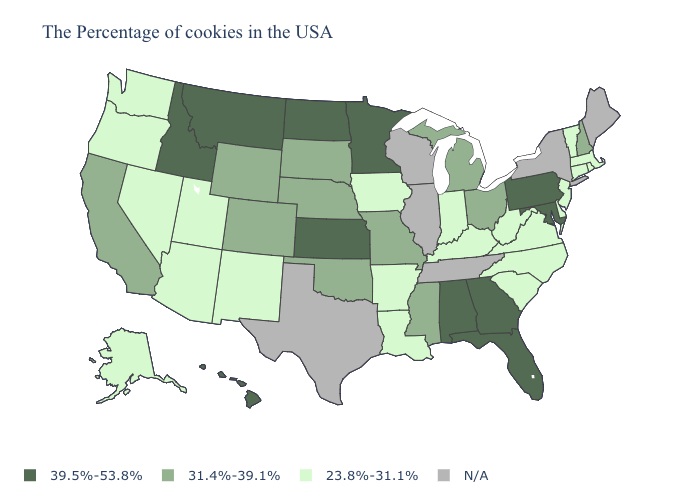What is the value of New Mexico?
Give a very brief answer. 23.8%-31.1%. Which states hav the highest value in the West?
Concise answer only. Montana, Idaho, Hawaii. Name the states that have a value in the range N/A?
Be succinct. Maine, New York, Tennessee, Wisconsin, Illinois, Texas. What is the value of Illinois?
Give a very brief answer. N/A. What is the value of South Carolina?
Give a very brief answer. 23.8%-31.1%. Among the states that border Missouri , which have the highest value?
Short answer required. Kansas. Is the legend a continuous bar?
Quick response, please. No. Name the states that have a value in the range 39.5%-53.8%?
Give a very brief answer. Maryland, Pennsylvania, Florida, Georgia, Alabama, Minnesota, Kansas, North Dakota, Montana, Idaho, Hawaii. Name the states that have a value in the range 39.5%-53.8%?
Give a very brief answer. Maryland, Pennsylvania, Florida, Georgia, Alabama, Minnesota, Kansas, North Dakota, Montana, Idaho, Hawaii. What is the value of Hawaii?
Answer briefly. 39.5%-53.8%. Which states have the lowest value in the USA?
Quick response, please. Massachusetts, Rhode Island, Vermont, Connecticut, New Jersey, Delaware, Virginia, North Carolina, South Carolina, West Virginia, Kentucky, Indiana, Louisiana, Arkansas, Iowa, New Mexico, Utah, Arizona, Nevada, Washington, Oregon, Alaska. Does the map have missing data?
Give a very brief answer. Yes. What is the value of Iowa?
Give a very brief answer. 23.8%-31.1%. Among the states that border Georgia , which have the highest value?
Concise answer only. Florida, Alabama. 